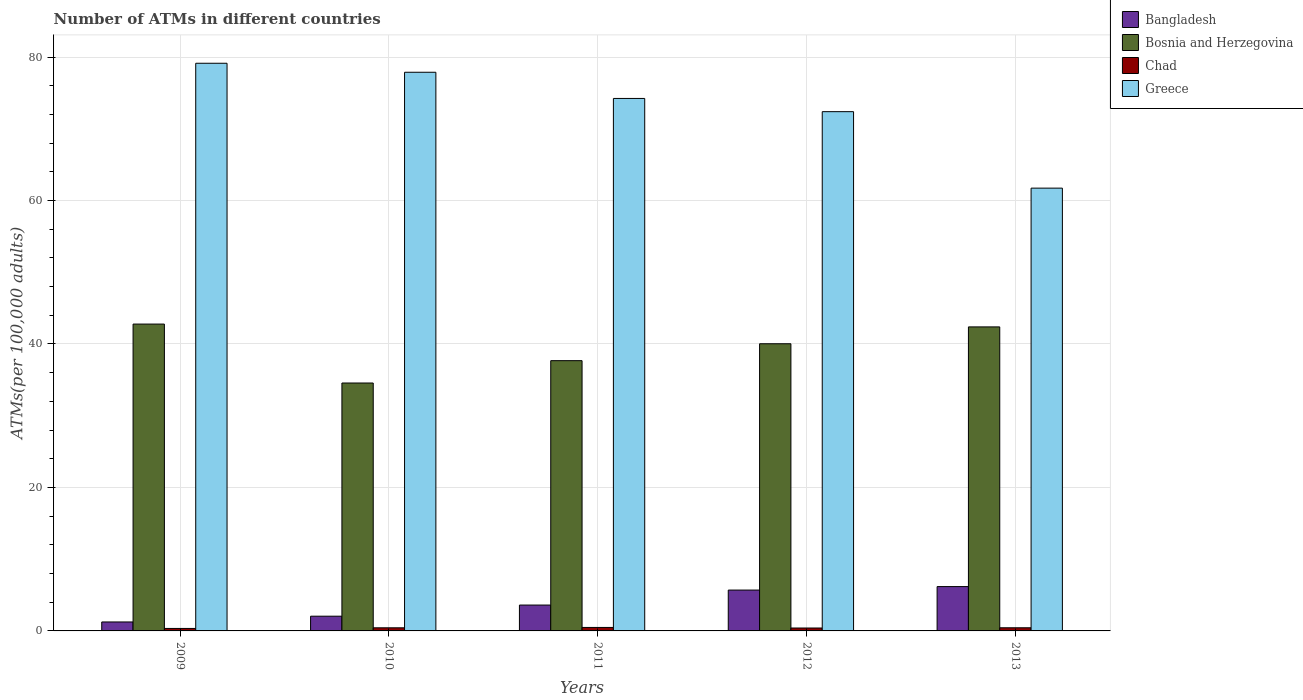How many different coloured bars are there?
Make the answer very short. 4. Are the number of bars per tick equal to the number of legend labels?
Offer a very short reply. Yes. Are the number of bars on each tick of the X-axis equal?
Your answer should be compact. Yes. What is the label of the 1st group of bars from the left?
Make the answer very short. 2009. In how many cases, is the number of bars for a given year not equal to the number of legend labels?
Your answer should be compact. 0. What is the number of ATMs in Bosnia and Herzegovina in 2010?
Offer a terse response. 34.56. Across all years, what is the maximum number of ATMs in Greece?
Keep it short and to the point. 79.14. Across all years, what is the minimum number of ATMs in Greece?
Your response must be concise. 61.73. In which year was the number of ATMs in Bangladesh maximum?
Make the answer very short. 2013. What is the total number of ATMs in Bosnia and Herzegovina in the graph?
Ensure brevity in your answer.  197.44. What is the difference between the number of ATMs in Bangladesh in 2010 and that in 2013?
Keep it short and to the point. -4.13. What is the difference between the number of ATMs in Chad in 2010 and the number of ATMs in Bangladesh in 2009?
Offer a very short reply. -0.82. What is the average number of ATMs in Chad per year?
Your answer should be compact. 0.42. In the year 2011, what is the difference between the number of ATMs in Bosnia and Herzegovina and number of ATMs in Chad?
Provide a succinct answer. 37.19. What is the ratio of the number of ATMs in Chad in 2009 to that in 2012?
Ensure brevity in your answer.  0.85. Is the number of ATMs in Chad in 2009 less than that in 2011?
Make the answer very short. Yes. Is the difference between the number of ATMs in Bosnia and Herzegovina in 2009 and 2010 greater than the difference between the number of ATMs in Chad in 2009 and 2010?
Give a very brief answer. Yes. What is the difference between the highest and the second highest number of ATMs in Chad?
Give a very brief answer. 0.05. What is the difference between the highest and the lowest number of ATMs in Greece?
Your answer should be compact. 17.41. Is the sum of the number of ATMs in Bangladesh in 2011 and 2012 greater than the maximum number of ATMs in Greece across all years?
Your answer should be compact. No. Is it the case that in every year, the sum of the number of ATMs in Bosnia and Herzegovina and number of ATMs in Chad is greater than the sum of number of ATMs in Bangladesh and number of ATMs in Greece?
Make the answer very short. Yes. Is it the case that in every year, the sum of the number of ATMs in Bangladesh and number of ATMs in Bosnia and Herzegovina is greater than the number of ATMs in Greece?
Your answer should be compact. No. What is the difference between two consecutive major ticks on the Y-axis?
Ensure brevity in your answer.  20. Are the values on the major ticks of Y-axis written in scientific E-notation?
Your answer should be very brief. No. Where does the legend appear in the graph?
Provide a short and direct response. Top right. How many legend labels are there?
Give a very brief answer. 4. How are the legend labels stacked?
Ensure brevity in your answer.  Vertical. What is the title of the graph?
Your response must be concise. Number of ATMs in different countries. What is the label or title of the Y-axis?
Offer a very short reply. ATMs(per 100,0 adults). What is the ATMs(per 100,000 adults) of Bangladesh in 2009?
Offer a very short reply. 1.25. What is the ATMs(per 100,000 adults) in Bosnia and Herzegovina in 2009?
Your answer should be compact. 42.78. What is the ATMs(per 100,000 adults) of Chad in 2009?
Keep it short and to the point. 0.34. What is the ATMs(per 100,000 adults) in Greece in 2009?
Ensure brevity in your answer.  79.14. What is the ATMs(per 100,000 adults) of Bangladesh in 2010?
Offer a terse response. 2.05. What is the ATMs(per 100,000 adults) in Bosnia and Herzegovina in 2010?
Provide a succinct answer. 34.56. What is the ATMs(per 100,000 adults) in Chad in 2010?
Provide a short and direct response. 0.43. What is the ATMs(per 100,000 adults) in Greece in 2010?
Give a very brief answer. 77.88. What is the ATMs(per 100,000 adults) of Bangladesh in 2011?
Ensure brevity in your answer.  3.61. What is the ATMs(per 100,000 adults) in Bosnia and Herzegovina in 2011?
Give a very brief answer. 37.68. What is the ATMs(per 100,000 adults) in Chad in 2011?
Keep it short and to the point. 0.48. What is the ATMs(per 100,000 adults) of Greece in 2011?
Offer a very short reply. 74.23. What is the ATMs(per 100,000 adults) in Bangladesh in 2012?
Provide a short and direct response. 5.7. What is the ATMs(per 100,000 adults) of Bosnia and Herzegovina in 2012?
Give a very brief answer. 40.03. What is the ATMs(per 100,000 adults) in Chad in 2012?
Keep it short and to the point. 0.41. What is the ATMs(per 100,000 adults) in Greece in 2012?
Your response must be concise. 72.39. What is the ATMs(per 100,000 adults) of Bangladesh in 2013?
Provide a short and direct response. 6.18. What is the ATMs(per 100,000 adults) in Bosnia and Herzegovina in 2013?
Offer a terse response. 42.38. What is the ATMs(per 100,000 adults) in Chad in 2013?
Provide a short and direct response. 0.44. What is the ATMs(per 100,000 adults) in Greece in 2013?
Offer a terse response. 61.73. Across all years, what is the maximum ATMs(per 100,000 adults) in Bangladesh?
Your response must be concise. 6.18. Across all years, what is the maximum ATMs(per 100,000 adults) of Bosnia and Herzegovina?
Keep it short and to the point. 42.78. Across all years, what is the maximum ATMs(per 100,000 adults) in Chad?
Offer a very short reply. 0.48. Across all years, what is the maximum ATMs(per 100,000 adults) in Greece?
Provide a short and direct response. 79.14. Across all years, what is the minimum ATMs(per 100,000 adults) in Bangladesh?
Your response must be concise. 1.25. Across all years, what is the minimum ATMs(per 100,000 adults) of Bosnia and Herzegovina?
Make the answer very short. 34.56. Across all years, what is the minimum ATMs(per 100,000 adults) in Chad?
Ensure brevity in your answer.  0.34. Across all years, what is the minimum ATMs(per 100,000 adults) in Greece?
Give a very brief answer. 61.73. What is the total ATMs(per 100,000 adults) in Bangladesh in the graph?
Provide a short and direct response. 18.79. What is the total ATMs(per 100,000 adults) of Bosnia and Herzegovina in the graph?
Ensure brevity in your answer.  197.44. What is the total ATMs(per 100,000 adults) in Chad in the graph?
Offer a very short reply. 2.11. What is the total ATMs(per 100,000 adults) in Greece in the graph?
Your answer should be very brief. 365.38. What is the difference between the ATMs(per 100,000 adults) in Bangladesh in 2009 and that in 2010?
Ensure brevity in your answer.  -0.8. What is the difference between the ATMs(per 100,000 adults) of Bosnia and Herzegovina in 2009 and that in 2010?
Make the answer very short. 8.22. What is the difference between the ATMs(per 100,000 adults) of Chad in 2009 and that in 2010?
Make the answer very short. -0.09. What is the difference between the ATMs(per 100,000 adults) of Greece in 2009 and that in 2010?
Keep it short and to the point. 1.25. What is the difference between the ATMs(per 100,000 adults) of Bangladesh in 2009 and that in 2011?
Give a very brief answer. -2.36. What is the difference between the ATMs(per 100,000 adults) in Bosnia and Herzegovina in 2009 and that in 2011?
Give a very brief answer. 5.1. What is the difference between the ATMs(per 100,000 adults) of Chad in 2009 and that in 2011?
Your answer should be very brief. -0.14. What is the difference between the ATMs(per 100,000 adults) of Greece in 2009 and that in 2011?
Give a very brief answer. 4.9. What is the difference between the ATMs(per 100,000 adults) in Bangladesh in 2009 and that in 2012?
Provide a short and direct response. -4.45. What is the difference between the ATMs(per 100,000 adults) in Bosnia and Herzegovina in 2009 and that in 2012?
Give a very brief answer. 2.74. What is the difference between the ATMs(per 100,000 adults) of Chad in 2009 and that in 2012?
Make the answer very short. -0.06. What is the difference between the ATMs(per 100,000 adults) in Greece in 2009 and that in 2012?
Give a very brief answer. 6.75. What is the difference between the ATMs(per 100,000 adults) of Bangladesh in 2009 and that in 2013?
Make the answer very short. -4.93. What is the difference between the ATMs(per 100,000 adults) of Bosnia and Herzegovina in 2009 and that in 2013?
Offer a very short reply. 0.39. What is the difference between the ATMs(per 100,000 adults) in Chad in 2009 and that in 2013?
Your answer should be very brief. -0.09. What is the difference between the ATMs(per 100,000 adults) of Greece in 2009 and that in 2013?
Give a very brief answer. 17.41. What is the difference between the ATMs(per 100,000 adults) of Bangladesh in 2010 and that in 2011?
Provide a succinct answer. -1.55. What is the difference between the ATMs(per 100,000 adults) in Bosnia and Herzegovina in 2010 and that in 2011?
Offer a terse response. -3.11. What is the difference between the ATMs(per 100,000 adults) of Chad in 2010 and that in 2011?
Give a very brief answer. -0.05. What is the difference between the ATMs(per 100,000 adults) in Greece in 2010 and that in 2011?
Your answer should be very brief. 3.65. What is the difference between the ATMs(per 100,000 adults) of Bangladesh in 2010 and that in 2012?
Provide a short and direct response. -3.64. What is the difference between the ATMs(per 100,000 adults) of Bosnia and Herzegovina in 2010 and that in 2012?
Provide a succinct answer. -5.47. What is the difference between the ATMs(per 100,000 adults) in Chad in 2010 and that in 2012?
Your answer should be compact. 0.03. What is the difference between the ATMs(per 100,000 adults) of Greece in 2010 and that in 2012?
Offer a very short reply. 5.49. What is the difference between the ATMs(per 100,000 adults) in Bangladesh in 2010 and that in 2013?
Your response must be concise. -4.13. What is the difference between the ATMs(per 100,000 adults) in Bosnia and Herzegovina in 2010 and that in 2013?
Keep it short and to the point. -7.82. What is the difference between the ATMs(per 100,000 adults) in Chad in 2010 and that in 2013?
Give a very brief answer. -0. What is the difference between the ATMs(per 100,000 adults) of Greece in 2010 and that in 2013?
Make the answer very short. 16.15. What is the difference between the ATMs(per 100,000 adults) in Bangladesh in 2011 and that in 2012?
Offer a very short reply. -2.09. What is the difference between the ATMs(per 100,000 adults) of Bosnia and Herzegovina in 2011 and that in 2012?
Offer a very short reply. -2.36. What is the difference between the ATMs(per 100,000 adults) of Chad in 2011 and that in 2012?
Your answer should be compact. 0.08. What is the difference between the ATMs(per 100,000 adults) in Greece in 2011 and that in 2012?
Your answer should be very brief. 1.84. What is the difference between the ATMs(per 100,000 adults) in Bangladesh in 2011 and that in 2013?
Your answer should be very brief. -2.57. What is the difference between the ATMs(per 100,000 adults) of Bosnia and Herzegovina in 2011 and that in 2013?
Offer a very short reply. -4.71. What is the difference between the ATMs(per 100,000 adults) of Chad in 2011 and that in 2013?
Make the answer very short. 0.05. What is the difference between the ATMs(per 100,000 adults) of Greece in 2011 and that in 2013?
Keep it short and to the point. 12.5. What is the difference between the ATMs(per 100,000 adults) of Bangladesh in 2012 and that in 2013?
Provide a succinct answer. -0.48. What is the difference between the ATMs(per 100,000 adults) in Bosnia and Herzegovina in 2012 and that in 2013?
Provide a short and direct response. -2.35. What is the difference between the ATMs(per 100,000 adults) of Chad in 2012 and that in 2013?
Provide a succinct answer. -0.03. What is the difference between the ATMs(per 100,000 adults) in Greece in 2012 and that in 2013?
Your answer should be compact. 10.66. What is the difference between the ATMs(per 100,000 adults) in Bangladesh in 2009 and the ATMs(per 100,000 adults) in Bosnia and Herzegovina in 2010?
Give a very brief answer. -33.31. What is the difference between the ATMs(per 100,000 adults) of Bangladesh in 2009 and the ATMs(per 100,000 adults) of Chad in 2010?
Provide a succinct answer. 0.82. What is the difference between the ATMs(per 100,000 adults) in Bangladesh in 2009 and the ATMs(per 100,000 adults) in Greece in 2010?
Offer a terse response. -76.63. What is the difference between the ATMs(per 100,000 adults) of Bosnia and Herzegovina in 2009 and the ATMs(per 100,000 adults) of Chad in 2010?
Provide a succinct answer. 42.34. What is the difference between the ATMs(per 100,000 adults) in Bosnia and Herzegovina in 2009 and the ATMs(per 100,000 adults) in Greece in 2010?
Offer a terse response. -35.11. What is the difference between the ATMs(per 100,000 adults) in Chad in 2009 and the ATMs(per 100,000 adults) in Greece in 2010?
Offer a very short reply. -77.54. What is the difference between the ATMs(per 100,000 adults) of Bangladesh in 2009 and the ATMs(per 100,000 adults) of Bosnia and Herzegovina in 2011?
Ensure brevity in your answer.  -36.43. What is the difference between the ATMs(per 100,000 adults) of Bangladesh in 2009 and the ATMs(per 100,000 adults) of Chad in 2011?
Offer a terse response. 0.77. What is the difference between the ATMs(per 100,000 adults) in Bangladesh in 2009 and the ATMs(per 100,000 adults) in Greece in 2011?
Offer a very short reply. -72.98. What is the difference between the ATMs(per 100,000 adults) of Bosnia and Herzegovina in 2009 and the ATMs(per 100,000 adults) of Chad in 2011?
Make the answer very short. 42.29. What is the difference between the ATMs(per 100,000 adults) in Bosnia and Herzegovina in 2009 and the ATMs(per 100,000 adults) in Greece in 2011?
Your response must be concise. -31.46. What is the difference between the ATMs(per 100,000 adults) of Chad in 2009 and the ATMs(per 100,000 adults) of Greece in 2011?
Your response must be concise. -73.89. What is the difference between the ATMs(per 100,000 adults) of Bangladesh in 2009 and the ATMs(per 100,000 adults) of Bosnia and Herzegovina in 2012?
Give a very brief answer. -38.78. What is the difference between the ATMs(per 100,000 adults) in Bangladesh in 2009 and the ATMs(per 100,000 adults) in Chad in 2012?
Keep it short and to the point. 0.84. What is the difference between the ATMs(per 100,000 adults) of Bangladesh in 2009 and the ATMs(per 100,000 adults) of Greece in 2012?
Your answer should be compact. -71.14. What is the difference between the ATMs(per 100,000 adults) of Bosnia and Herzegovina in 2009 and the ATMs(per 100,000 adults) of Chad in 2012?
Make the answer very short. 42.37. What is the difference between the ATMs(per 100,000 adults) in Bosnia and Herzegovina in 2009 and the ATMs(per 100,000 adults) in Greece in 2012?
Make the answer very short. -29.61. What is the difference between the ATMs(per 100,000 adults) of Chad in 2009 and the ATMs(per 100,000 adults) of Greece in 2012?
Your answer should be very brief. -72.05. What is the difference between the ATMs(per 100,000 adults) in Bangladesh in 2009 and the ATMs(per 100,000 adults) in Bosnia and Herzegovina in 2013?
Offer a very short reply. -41.13. What is the difference between the ATMs(per 100,000 adults) in Bangladesh in 2009 and the ATMs(per 100,000 adults) in Chad in 2013?
Your answer should be very brief. 0.81. What is the difference between the ATMs(per 100,000 adults) of Bangladesh in 2009 and the ATMs(per 100,000 adults) of Greece in 2013?
Give a very brief answer. -60.48. What is the difference between the ATMs(per 100,000 adults) in Bosnia and Herzegovina in 2009 and the ATMs(per 100,000 adults) in Chad in 2013?
Your response must be concise. 42.34. What is the difference between the ATMs(per 100,000 adults) in Bosnia and Herzegovina in 2009 and the ATMs(per 100,000 adults) in Greece in 2013?
Provide a succinct answer. -18.95. What is the difference between the ATMs(per 100,000 adults) of Chad in 2009 and the ATMs(per 100,000 adults) of Greece in 2013?
Offer a very short reply. -61.39. What is the difference between the ATMs(per 100,000 adults) in Bangladesh in 2010 and the ATMs(per 100,000 adults) in Bosnia and Herzegovina in 2011?
Offer a terse response. -35.62. What is the difference between the ATMs(per 100,000 adults) in Bangladesh in 2010 and the ATMs(per 100,000 adults) in Chad in 2011?
Your response must be concise. 1.57. What is the difference between the ATMs(per 100,000 adults) in Bangladesh in 2010 and the ATMs(per 100,000 adults) in Greece in 2011?
Offer a very short reply. -72.18. What is the difference between the ATMs(per 100,000 adults) of Bosnia and Herzegovina in 2010 and the ATMs(per 100,000 adults) of Chad in 2011?
Provide a succinct answer. 34.08. What is the difference between the ATMs(per 100,000 adults) in Bosnia and Herzegovina in 2010 and the ATMs(per 100,000 adults) in Greece in 2011?
Provide a short and direct response. -39.67. What is the difference between the ATMs(per 100,000 adults) of Chad in 2010 and the ATMs(per 100,000 adults) of Greece in 2011?
Keep it short and to the point. -73.8. What is the difference between the ATMs(per 100,000 adults) of Bangladesh in 2010 and the ATMs(per 100,000 adults) of Bosnia and Herzegovina in 2012?
Give a very brief answer. -37.98. What is the difference between the ATMs(per 100,000 adults) of Bangladesh in 2010 and the ATMs(per 100,000 adults) of Chad in 2012?
Your response must be concise. 1.65. What is the difference between the ATMs(per 100,000 adults) of Bangladesh in 2010 and the ATMs(per 100,000 adults) of Greece in 2012?
Give a very brief answer. -70.34. What is the difference between the ATMs(per 100,000 adults) of Bosnia and Herzegovina in 2010 and the ATMs(per 100,000 adults) of Chad in 2012?
Your response must be concise. 34.16. What is the difference between the ATMs(per 100,000 adults) in Bosnia and Herzegovina in 2010 and the ATMs(per 100,000 adults) in Greece in 2012?
Offer a terse response. -37.83. What is the difference between the ATMs(per 100,000 adults) in Chad in 2010 and the ATMs(per 100,000 adults) in Greece in 2012?
Your answer should be very brief. -71.96. What is the difference between the ATMs(per 100,000 adults) in Bangladesh in 2010 and the ATMs(per 100,000 adults) in Bosnia and Herzegovina in 2013?
Make the answer very short. -40.33. What is the difference between the ATMs(per 100,000 adults) in Bangladesh in 2010 and the ATMs(per 100,000 adults) in Chad in 2013?
Offer a very short reply. 1.62. What is the difference between the ATMs(per 100,000 adults) of Bangladesh in 2010 and the ATMs(per 100,000 adults) of Greece in 2013?
Give a very brief answer. -59.68. What is the difference between the ATMs(per 100,000 adults) of Bosnia and Herzegovina in 2010 and the ATMs(per 100,000 adults) of Chad in 2013?
Provide a short and direct response. 34.12. What is the difference between the ATMs(per 100,000 adults) in Bosnia and Herzegovina in 2010 and the ATMs(per 100,000 adults) in Greece in 2013?
Ensure brevity in your answer.  -27.17. What is the difference between the ATMs(per 100,000 adults) of Chad in 2010 and the ATMs(per 100,000 adults) of Greece in 2013?
Your answer should be very brief. -61.3. What is the difference between the ATMs(per 100,000 adults) in Bangladesh in 2011 and the ATMs(per 100,000 adults) in Bosnia and Herzegovina in 2012?
Offer a terse response. -36.43. What is the difference between the ATMs(per 100,000 adults) of Bangladesh in 2011 and the ATMs(per 100,000 adults) of Chad in 2012?
Offer a terse response. 3.2. What is the difference between the ATMs(per 100,000 adults) of Bangladesh in 2011 and the ATMs(per 100,000 adults) of Greece in 2012?
Make the answer very short. -68.78. What is the difference between the ATMs(per 100,000 adults) in Bosnia and Herzegovina in 2011 and the ATMs(per 100,000 adults) in Chad in 2012?
Give a very brief answer. 37.27. What is the difference between the ATMs(per 100,000 adults) of Bosnia and Herzegovina in 2011 and the ATMs(per 100,000 adults) of Greece in 2012?
Provide a short and direct response. -34.71. What is the difference between the ATMs(per 100,000 adults) of Chad in 2011 and the ATMs(per 100,000 adults) of Greece in 2012?
Offer a very short reply. -71.91. What is the difference between the ATMs(per 100,000 adults) in Bangladesh in 2011 and the ATMs(per 100,000 adults) in Bosnia and Herzegovina in 2013?
Your response must be concise. -38.78. What is the difference between the ATMs(per 100,000 adults) of Bangladesh in 2011 and the ATMs(per 100,000 adults) of Chad in 2013?
Provide a succinct answer. 3.17. What is the difference between the ATMs(per 100,000 adults) of Bangladesh in 2011 and the ATMs(per 100,000 adults) of Greece in 2013?
Provide a succinct answer. -58.12. What is the difference between the ATMs(per 100,000 adults) of Bosnia and Herzegovina in 2011 and the ATMs(per 100,000 adults) of Chad in 2013?
Make the answer very short. 37.24. What is the difference between the ATMs(per 100,000 adults) of Bosnia and Herzegovina in 2011 and the ATMs(per 100,000 adults) of Greece in 2013?
Provide a succinct answer. -24.05. What is the difference between the ATMs(per 100,000 adults) in Chad in 2011 and the ATMs(per 100,000 adults) in Greece in 2013?
Your response must be concise. -61.25. What is the difference between the ATMs(per 100,000 adults) of Bangladesh in 2012 and the ATMs(per 100,000 adults) of Bosnia and Herzegovina in 2013?
Provide a succinct answer. -36.69. What is the difference between the ATMs(per 100,000 adults) in Bangladesh in 2012 and the ATMs(per 100,000 adults) in Chad in 2013?
Offer a terse response. 5.26. What is the difference between the ATMs(per 100,000 adults) in Bangladesh in 2012 and the ATMs(per 100,000 adults) in Greece in 2013?
Your answer should be compact. -56.03. What is the difference between the ATMs(per 100,000 adults) in Bosnia and Herzegovina in 2012 and the ATMs(per 100,000 adults) in Chad in 2013?
Keep it short and to the point. 39.6. What is the difference between the ATMs(per 100,000 adults) in Bosnia and Herzegovina in 2012 and the ATMs(per 100,000 adults) in Greece in 2013?
Your answer should be very brief. -21.7. What is the difference between the ATMs(per 100,000 adults) in Chad in 2012 and the ATMs(per 100,000 adults) in Greece in 2013?
Give a very brief answer. -61.32. What is the average ATMs(per 100,000 adults) of Bangladesh per year?
Make the answer very short. 3.76. What is the average ATMs(per 100,000 adults) in Bosnia and Herzegovina per year?
Give a very brief answer. 39.49. What is the average ATMs(per 100,000 adults) in Chad per year?
Provide a short and direct response. 0.42. What is the average ATMs(per 100,000 adults) in Greece per year?
Make the answer very short. 73.08. In the year 2009, what is the difference between the ATMs(per 100,000 adults) in Bangladesh and ATMs(per 100,000 adults) in Bosnia and Herzegovina?
Offer a terse response. -41.53. In the year 2009, what is the difference between the ATMs(per 100,000 adults) in Bangladesh and ATMs(per 100,000 adults) in Chad?
Your answer should be very brief. 0.91. In the year 2009, what is the difference between the ATMs(per 100,000 adults) of Bangladesh and ATMs(per 100,000 adults) of Greece?
Provide a short and direct response. -77.89. In the year 2009, what is the difference between the ATMs(per 100,000 adults) in Bosnia and Herzegovina and ATMs(per 100,000 adults) in Chad?
Make the answer very short. 42.43. In the year 2009, what is the difference between the ATMs(per 100,000 adults) in Bosnia and Herzegovina and ATMs(per 100,000 adults) in Greece?
Your answer should be very brief. -36.36. In the year 2009, what is the difference between the ATMs(per 100,000 adults) in Chad and ATMs(per 100,000 adults) in Greece?
Give a very brief answer. -78.79. In the year 2010, what is the difference between the ATMs(per 100,000 adults) in Bangladesh and ATMs(per 100,000 adults) in Bosnia and Herzegovina?
Make the answer very short. -32.51. In the year 2010, what is the difference between the ATMs(per 100,000 adults) in Bangladesh and ATMs(per 100,000 adults) in Chad?
Provide a short and direct response. 1.62. In the year 2010, what is the difference between the ATMs(per 100,000 adults) in Bangladesh and ATMs(per 100,000 adults) in Greece?
Offer a very short reply. -75.83. In the year 2010, what is the difference between the ATMs(per 100,000 adults) of Bosnia and Herzegovina and ATMs(per 100,000 adults) of Chad?
Make the answer very short. 34.13. In the year 2010, what is the difference between the ATMs(per 100,000 adults) in Bosnia and Herzegovina and ATMs(per 100,000 adults) in Greece?
Ensure brevity in your answer.  -43.32. In the year 2010, what is the difference between the ATMs(per 100,000 adults) of Chad and ATMs(per 100,000 adults) of Greece?
Provide a short and direct response. -77.45. In the year 2011, what is the difference between the ATMs(per 100,000 adults) in Bangladesh and ATMs(per 100,000 adults) in Bosnia and Herzegovina?
Your answer should be very brief. -34.07. In the year 2011, what is the difference between the ATMs(per 100,000 adults) in Bangladesh and ATMs(per 100,000 adults) in Chad?
Offer a terse response. 3.12. In the year 2011, what is the difference between the ATMs(per 100,000 adults) of Bangladesh and ATMs(per 100,000 adults) of Greece?
Offer a terse response. -70.63. In the year 2011, what is the difference between the ATMs(per 100,000 adults) of Bosnia and Herzegovina and ATMs(per 100,000 adults) of Chad?
Your answer should be very brief. 37.19. In the year 2011, what is the difference between the ATMs(per 100,000 adults) in Bosnia and Herzegovina and ATMs(per 100,000 adults) in Greece?
Offer a very short reply. -36.56. In the year 2011, what is the difference between the ATMs(per 100,000 adults) of Chad and ATMs(per 100,000 adults) of Greece?
Give a very brief answer. -73.75. In the year 2012, what is the difference between the ATMs(per 100,000 adults) of Bangladesh and ATMs(per 100,000 adults) of Bosnia and Herzegovina?
Keep it short and to the point. -34.34. In the year 2012, what is the difference between the ATMs(per 100,000 adults) in Bangladesh and ATMs(per 100,000 adults) in Chad?
Your answer should be compact. 5.29. In the year 2012, what is the difference between the ATMs(per 100,000 adults) of Bangladesh and ATMs(per 100,000 adults) of Greece?
Your answer should be very brief. -66.69. In the year 2012, what is the difference between the ATMs(per 100,000 adults) of Bosnia and Herzegovina and ATMs(per 100,000 adults) of Chad?
Offer a very short reply. 39.63. In the year 2012, what is the difference between the ATMs(per 100,000 adults) of Bosnia and Herzegovina and ATMs(per 100,000 adults) of Greece?
Make the answer very short. -32.36. In the year 2012, what is the difference between the ATMs(per 100,000 adults) of Chad and ATMs(per 100,000 adults) of Greece?
Provide a short and direct response. -71.98. In the year 2013, what is the difference between the ATMs(per 100,000 adults) of Bangladesh and ATMs(per 100,000 adults) of Bosnia and Herzegovina?
Keep it short and to the point. -36.2. In the year 2013, what is the difference between the ATMs(per 100,000 adults) in Bangladesh and ATMs(per 100,000 adults) in Chad?
Your response must be concise. 5.74. In the year 2013, what is the difference between the ATMs(per 100,000 adults) in Bangladesh and ATMs(per 100,000 adults) in Greece?
Ensure brevity in your answer.  -55.55. In the year 2013, what is the difference between the ATMs(per 100,000 adults) of Bosnia and Herzegovina and ATMs(per 100,000 adults) of Chad?
Make the answer very short. 41.95. In the year 2013, what is the difference between the ATMs(per 100,000 adults) in Bosnia and Herzegovina and ATMs(per 100,000 adults) in Greece?
Your answer should be compact. -19.35. In the year 2013, what is the difference between the ATMs(per 100,000 adults) of Chad and ATMs(per 100,000 adults) of Greece?
Offer a very short reply. -61.29. What is the ratio of the ATMs(per 100,000 adults) in Bangladesh in 2009 to that in 2010?
Offer a very short reply. 0.61. What is the ratio of the ATMs(per 100,000 adults) of Bosnia and Herzegovina in 2009 to that in 2010?
Your answer should be very brief. 1.24. What is the ratio of the ATMs(per 100,000 adults) in Chad in 2009 to that in 2010?
Ensure brevity in your answer.  0.79. What is the ratio of the ATMs(per 100,000 adults) in Greece in 2009 to that in 2010?
Your answer should be compact. 1.02. What is the ratio of the ATMs(per 100,000 adults) in Bangladesh in 2009 to that in 2011?
Offer a terse response. 0.35. What is the ratio of the ATMs(per 100,000 adults) in Bosnia and Herzegovina in 2009 to that in 2011?
Your response must be concise. 1.14. What is the ratio of the ATMs(per 100,000 adults) of Chad in 2009 to that in 2011?
Give a very brief answer. 0.71. What is the ratio of the ATMs(per 100,000 adults) in Greece in 2009 to that in 2011?
Ensure brevity in your answer.  1.07. What is the ratio of the ATMs(per 100,000 adults) of Bangladesh in 2009 to that in 2012?
Your answer should be very brief. 0.22. What is the ratio of the ATMs(per 100,000 adults) of Bosnia and Herzegovina in 2009 to that in 2012?
Give a very brief answer. 1.07. What is the ratio of the ATMs(per 100,000 adults) of Chad in 2009 to that in 2012?
Provide a succinct answer. 0.85. What is the ratio of the ATMs(per 100,000 adults) in Greece in 2009 to that in 2012?
Your answer should be very brief. 1.09. What is the ratio of the ATMs(per 100,000 adults) of Bangladesh in 2009 to that in 2013?
Give a very brief answer. 0.2. What is the ratio of the ATMs(per 100,000 adults) in Bosnia and Herzegovina in 2009 to that in 2013?
Your answer should be compact. 1.01. What is the ratio of the ATMs(per 100,000 adults) in Chad in 2009 to that in 2013?
Make the answer very short. 0.79. What is the ratio of the ATMs(per 100,000 adults) of Greece in 2009 to that in 2013?
Keep it short and to the point. 1.28. What is the ratio of the ATMs(per 100,000 adults) in Bangladesh in 2010 to that in 2011?
Your answer should be very brief. 0.57. What is the ratio of the ATMs(per 100,000 adults) in Bosnia and Herzegovina in 2010 to that in 2011?
Your response must be concise. 0.92. What is the ratio of the ATMs(per 100,000 adults) in Chad in 2010 to that in 2011?
Your response must be concise. 0.9. What is the ratio of the ATMs(per 100,000 adults) in Greece in 2010 to that in 2011?
Keep it short and to the point. 1.05. What is the ratio of the ATMs(per 100,000 adults) of Bangladesh in 2010 to that in 2012?
Ensure brevity in your answer.  0.36. What is the ratio of the ATMs(per 100,000 adults) in Bosnia and Herzegovina in 2010 to that in 2012?
Make the answer very short. 0.86. What is the ratio of the ATMs(per 100,000 adults) of Chad in 2010 to that in 2012?
Offer a terse response. 1.07. What is the ratio of the ATMs(per 100,000 adults) in Greece in 2010 to that in 2012?
Your response must be concise. 1.08. What is the ratio of the ATMs(per 100,000 adults) in Bangladesh in 2010 to that in 2013?
Provide a short and direct response. 0.33. What is the ratio of the ATMs(per 100,000 adults) in Bosnia and Herzegovina in 2010 to that in 2013?
Make the answer very short. 0.82. What is the ratio of the ATMs(per 100,000 adults) of Chad in 2010 to that in 2013?
Provide a succinct answer. 0.99. What is the ratio of the ATMs(per 100,000 adults) of Greece in 2010 to that in 2013?
Keep it short and to the point. 1.26. What is the ratio of the ATMs(per 100,000 adults) in Bangladesh in 2011 to that in 2012?
Provide a short and direct response. 0.63. What is the ratio of the ATMs(per 100,000 adults) of Bosnia and Herzegovina in 2011 to that in 2012?
Ensure brevity in your answer.  0.94. What is the ratio of the ATMs(per 100,000 adults) in Chad in 2011 to that in 2012?
Provide a succinct answer. 1.19. What is the ratio of the ATMs(per 100,000 adults) in Greece in 2011 to that in 2012?
Your answer should be compact. 1.03. What is the ratio of the ATMs(per 100,000 adults) in Bangladesh in 2011 to that in 2013?
Give a very brief answer. 0.58. What is the ratio of the ATMs(per 100,000 adults) in Bosnia and Herzegovina in 2011 to that in 2013?
Provide a succinct answer. 0.89. What is the ratio of the ATMs(per 100,000 adults) of Chad in 2011 to that in 2013?
Make the answer very short. 1.1. What is the ratio of the ATMs(per 100,000 adults) of Greece in 2011 to that in 2013?
Make the answer very short. 1.2. What is the ratio of the ATMs(per 100,000 adults) in Bangladesh in 2012 to that in 2013?
Ensure brevity in your answer.  0.92. What is the ratio of the ATMs(per 100,000 adults) in Bosnia and Herzegovina in 2012 to that in 2013?
Offer a terse response. 0.94. What is the ratio of the ATMs(per 100,000 adults) of Chad in 2012 to that in 2013?
Keep it short and to the point. 0.93. What is the ratio of the ATMs(per 100,000 adults) of Greece in 2012 to that in 2013?
Keep it short and to the point. 1.17. What is the difference between the highest and the second highest ATMs(per 100,000 adults) of Bangladesh?
Give a very brief answer. 0.48. What is the difference between the highest and the second highest ATMs(per 100,000 adults) in Bosnia and Herzegovina?
Ensure brevity in your answer.  0.39. What is the difference between the highest and the second highest ATMs(per 100,000 adults) of Chad?
Offer a terse response. 0.05. What is the difference between the highest and the second highest ATMs(per 100,000 adults) of Greece?
Give a very brief answer. 1.25. What is the difference between the highest and the lowest ATMs(per 100,000 adults) of Bangladesh?
Ensure brevity in your answer.  4.93. What is the difference between the highest and the lowest ATMs(per 100,000 adults) in Bosnia and Herzegovina?
Your answer should be compact. 8.22. What is the difference between the highest and the lowest ATMs(per 100,000 adults) of Chad?
Your answer should be compact. 0.14. What is the difference between the highest and the lowest ATMs(per 100,000 adults) in Greece?
Ensure brevity in your answer.  17.41. 